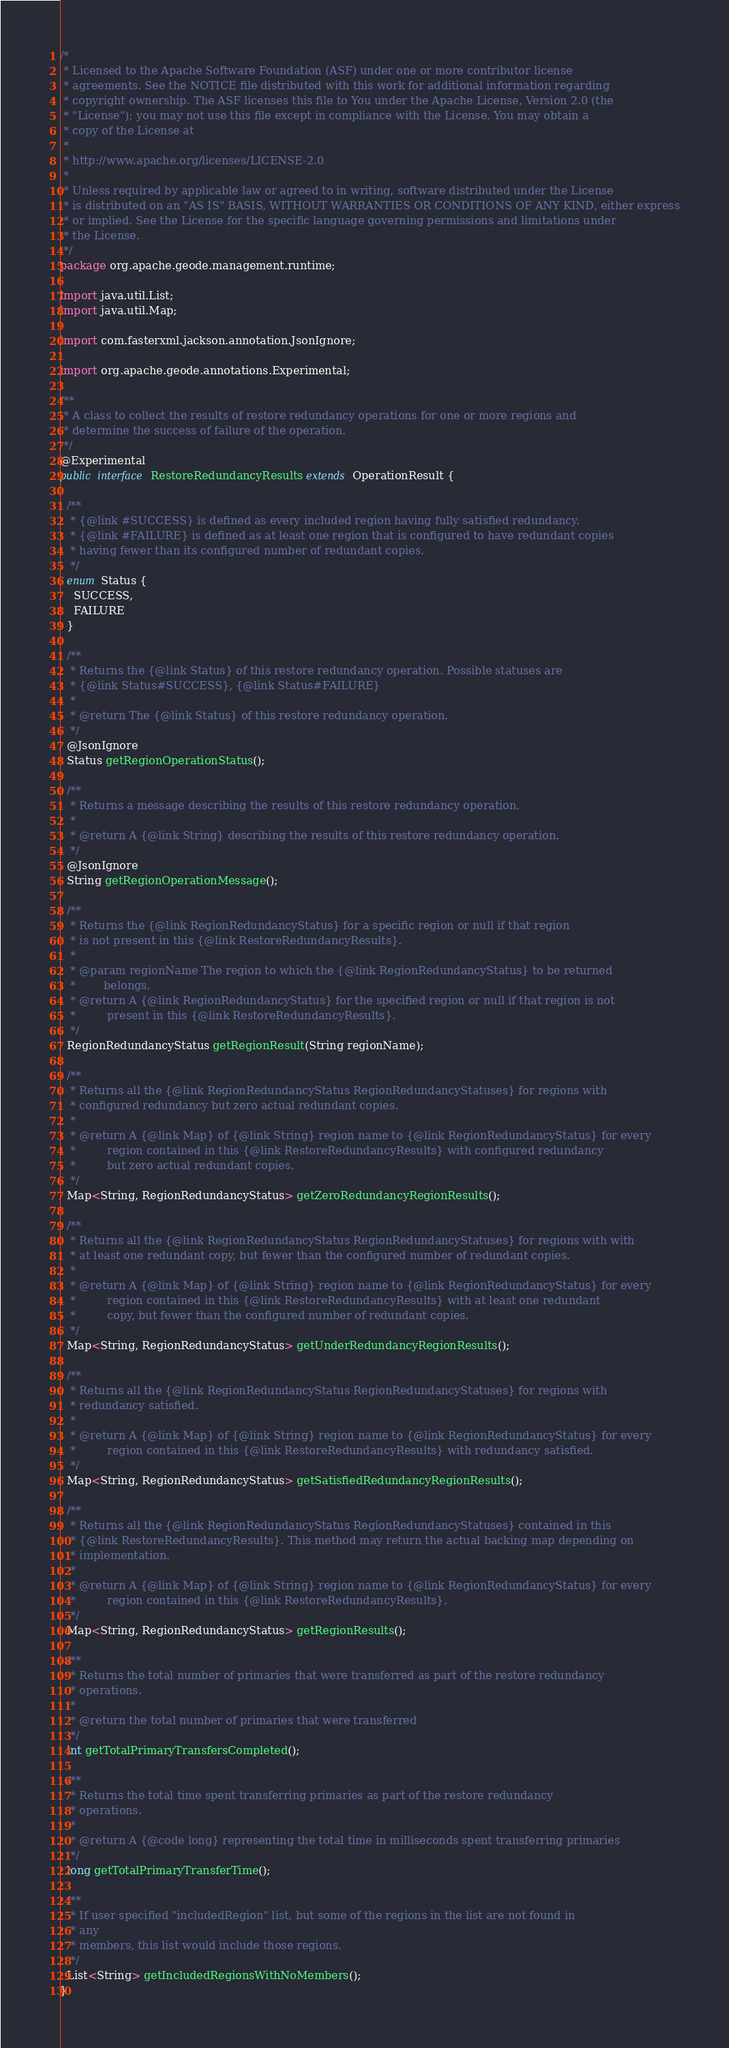<code> <loc_0><loc_0><loc_500><loc_500><_Java_>/*
 * Licensed to the Apache Software Foundation (ASF) under one or more contributor license
 * agreements. See the NOTICE file distributed with this work for additional information regarding
 * copyright ownership. The ASF licenses this file to You under the Apache License, Version 2.0 (the
 * "License"); you may not use this file except in compliance with the License. You may obtain a
 * copy of the License at
 *
 * http://www.apache.org/licenses/LICENSE-2.0
 *
 * Unless required by applicable law or agreed to in writing, software distributed under the License
 * is distributed on an "AS IS" BASIS, WITHOUT WARRANTIES OR CONDITIONS OF ANY KIND, either express
 * or implied. See the License for the specific language governing permissions and limitations under
 * the License.
 */
package org.apache.geode.management.runtime;

import java.util.List;
import java.util.Map;

import com.fasterxml.jackson.annotation.JsonIgnore;

import org.apache.geode.annotations.Experimental;

/**
 * A class to collect the results of restore redundancy operations for one or more regions and
 * determine the success of failure of the operation.
 */
@Experimental
public interface RestoreRedundancyResults extends OperationResult {

  /**
   * {@link #SUCCESS} is defined as every included region having fully satisfied redundancy.
   * {@link #FAILURE} is defined as at least one region that is configured to have redundant copies
   * having fewer than its configured number of redundant copies.
   */
  enum Status {
    SUCCESS,
    FAILURE
  }

  /**
   * Returns the {@link Status} of this restore redundancy operation. Possible statuses are
   * {@link Status#SUCCESS}, {@link Status#FAILURE}
   *
   * @return The {@link Status} of this restore redundancy operation.
   */
  @JsonIgnore
  Status getRegionOperationStatus();

  /**
   * Returns a message describing the results of this restore redundancy operation.
   *
   * @return A {@link String} describing the results of this restore redundancy operation.
   */
  @JsonIgnore
  String getRegionOperationMessage();

  /**
   * Returns the {@link RegionRedundancyStatus} for a specific region or null if that region
   * is not present in this {@link RestoreRedundancyResults}.
   *
   * @param regionName The region to which the {@link RegionRedundancyStatus} to be returned
   *        belongs.
   * @return A {@link RegionRedundancyStatus} for the specified region or null if that region is not
   *         present in this {@link RestoreRedundancyResults}.
   */
  RegionRedundancyStatus getRegionResult(String regionName);

  /**
   * Returns all the {@link RegionRedundancyStatus RegionRedundancyStatuses} for regions with
   * configured redundancy but zero actual redundant copies.
   *
   * @return A {@link Map} of {@link String} region name to {@link RegionRedundancyStatus} for every
   *         region contained in this {@link RestoreRedundancyResults} with configured redundancy
   *         but zero actual redundant copies.
   */
  Map<String, RegionRedundancyStatus> getZeroRedundancyRegionResults();

  /**
   * Returns all the {@link RegionRedundancyStatus RegionRedundancyStatuses} for regions with with
   * at least one redundant copy, but fewer than the configured number of redundant copies.
   *
   * @return A {@link Map} of {@link String} region name to {@link RegionRedundancyStatus} for every
   *         region contained in this {@link RestoreRedundancyResults} with at least one redundant
   *         copy, but fewer than the configured number of redundant copies.
   */
  Map<String, RegionRedundancyStatus> getUnderRedundancyRegionResults();

  /**
   * Returns all the {@link RegionRedundancyStatus RegionRedundancyStatuses} for regions with
   * redundancy satisfied.
   *
   * @return A {@link Map} of {@link String} region name to {@link RegionRedundancyStatus} for every
   *         region contained in this {@link RestoreRedundancyResults} with redundancy satisfied.
   */
  Map<String, RegionRedundancyStatus> getSatisfiedRedundancyRegionResults();

  /**
   * Returns all the {@link RegionRedundancyStatus RegionRedundancyStatuses} contained in this
   * {@link RestoreRedundancyResults}. This method may return the actual backing map depending on
   * implementation.
   *
   * @return A {@link Map} of {@link String} region name to {@link RegionRedundancyStatus} for every
   *         region contained in this {@link RestoreRedundancyResults}.
   */
  Map<String, RegionRedundancyStatus> getRegionResults();

  /**
   * Returns the total number of primaries that were transferred as part of the restore redundancy
   * operations.
   *
   * @return the total number of primaries that were transferred
   */
  int getTotalPrimaryTransfersCompleted();

  /**
   * Returns the total time spent transferring primaries as part of the restore redundancy
   * operations.
   *
   * @return A {@code long} representing the total time in milliseconds spent transferring primaries
   */
  long getTotalPrimaryTransferTime();

  /**
   * If user specified "includedRegion" list, but some of the regions in the list are not found in
   * any
   * members, this list would include those regions.
   */
  List<String> getIncludedRegionsWithNoMembers();
}
</code> 